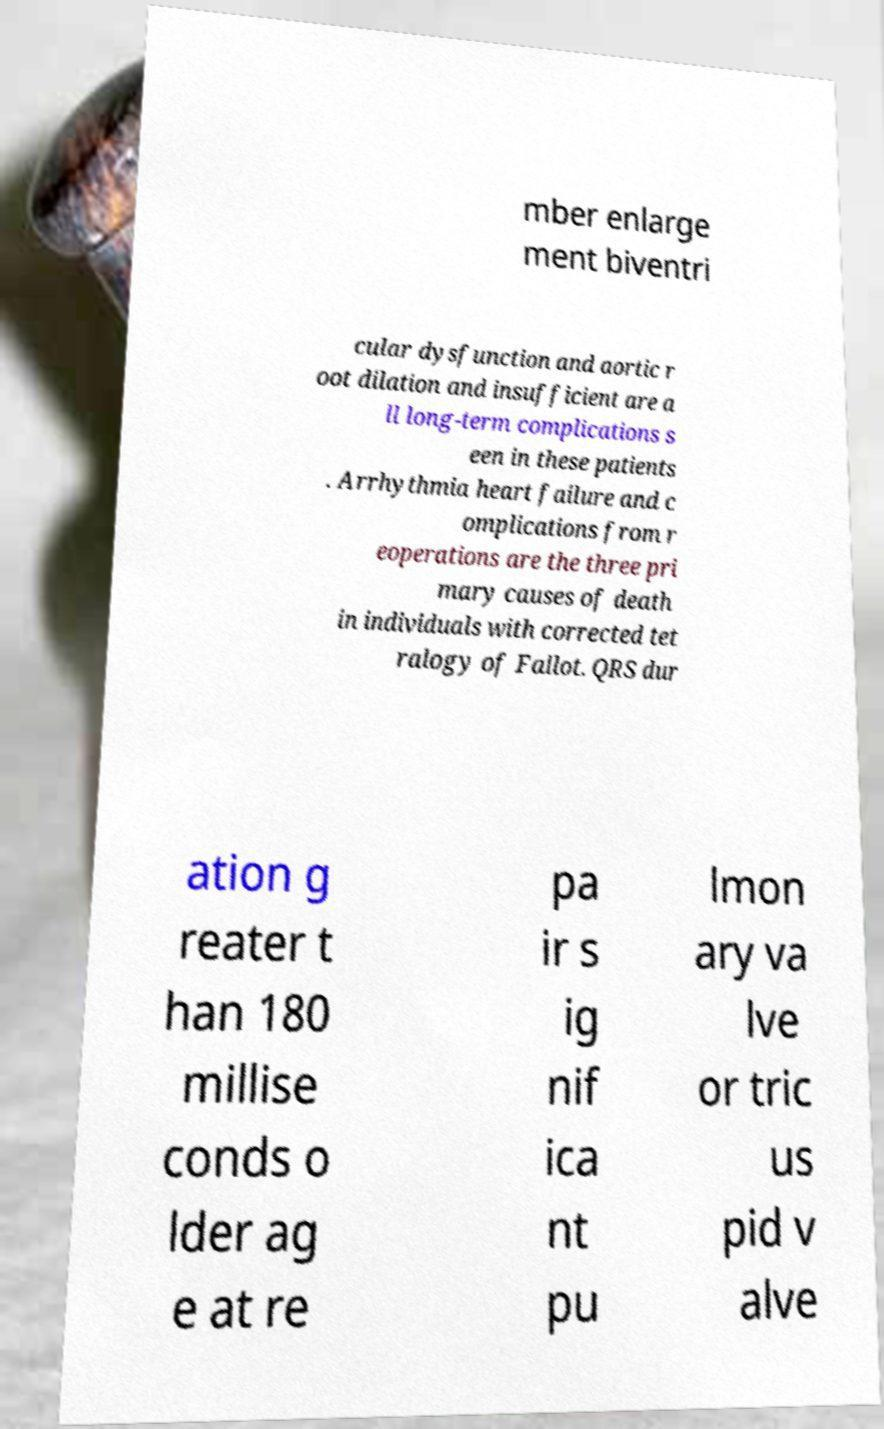Can you read and provide the text displayed in the image?This photo seems to have some interesting text. Can you extract and type it out for me? mber enlarge ment biventri cular dysfunction and aortic r oot dilation and insufficient are a ll long-term complications s een in these patients . Arrhythmia heart failure and c omplications from r eoperations are the three pri mary causes of death in individuals with corrected tet ralogy of Fallot. QRS dur ation g reater t han 180 millise conds o lder ag e at re pa ir s ig nif ica nt pu lmon ary va lve or tric us pid v alve 